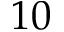Convert formula to latex. <formula><loc_0><loc_0><loc_500><loc_500>1 0</formula> 